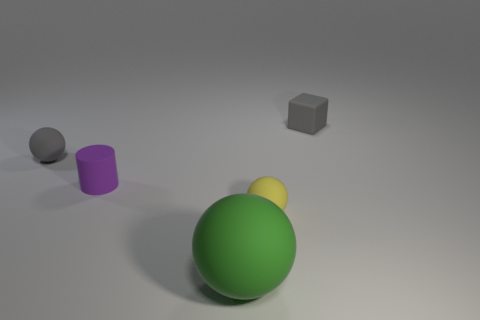Do the tiny block and the small ball that is behind the purple rubber object have the same color?
Offer a terse response. Yes. The gray object behind the matte ball left of the large green object is made of what material?
Ensure brevity in your answer.  Rubber. The large sphere that is made of the same material as the small gray block is what color?
Give a very brief answer. Green. There is a small matte object that is the same color as the small matte block; what is its shape?
Provide a succinct answer. Sphere. Is the size of the sphere behind the tiny yellow matte sphere the same as the matte ball that is in front of the tiny yellow matte object?
Provide a short and direct response. No. How many cubes are either big gray metallic objects or tiny purple rubber things?
Your answer should be very brief. 0. Do the gray object that is right of the gray sphere and the purple cylinder have the same material?
Ensure brevity in your answer.  Yes. How many other objects are there of the same size as the green thing?
Your answer should be compact. 0. What number of small objects are either green things or green rubber cylinders?
Your answer should be very brief. 0. Does the tiny rubber cylinder have the same color as the large matte object?
Ensure brevity in your answer.  No. 